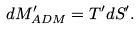Convert formula to latex. <formula><loc_0><loc_0><loc_500><loc_500>d M _ { A D M } ^ { \prime } = T ^ { \prime } d { S } ^ { \prime } .</formula> 